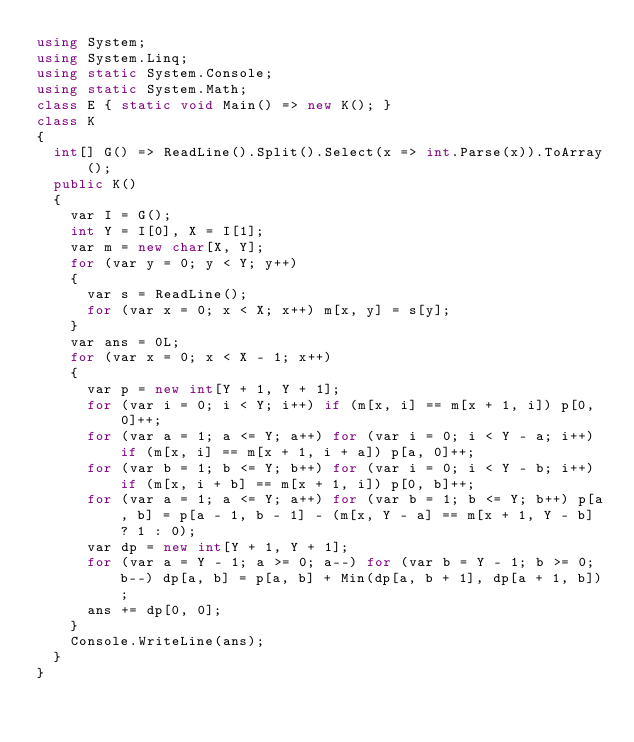<code> <loc_0><loc_0><loc_500><loc_500><_C#_>using System;
using System.Linq;
using static System.Console;
using static System.Math;
class E { static void Main() => new K(); }
class K
{
	int[] G() => ReadLine().Split().Select(x => int.Parse(x)).ToArray();
	public K()
	{
		var I = G();
		int Y = I[0], X = I[1];
		var m = new char[X, Y];
		for (var y = 0; y < Y; y++)
		{
			var s = ReadLine();
			for (var x = 0; x < X; x++) m[x, y] = s[y];
		}
		var ans = 0L;
		for (var x = 0; x < X - 1; x++)
		{
			var p = new int[Y + 1, Y + 1];
			for (var i = 0; i < Y; i++) if (m[x, i] == m[x + 1, i]) p[0, 0]++;
			for (var a = 1; a <= Y; a++) for (var i = 0; i < Y - a; i++) if (m[x, i] == m[x + 1, i + a]) p[a, 0]++;
			for (var b = 1; b <= Y; b++) for (var i = 0; i < Y - b; i++) if (m[x, i + b] == m[x + 1, i]) p[0, b]++;
			for (var a = 1; a <= Y; a++) for (var b = 1; b <= Y; b++) p[a, b] = p[a - 1, b - 1] - (m[x, Y - a] == m[x + 1, Y - b] ? 1 : 0);
			var dp = new int[Y + 1, Y + 1];
			for (var a = Y - 1; a >= 0; a--) for (var b = Y - 1; b >= 0; b--) dp[a, b] = p[a, b] + Min(dp[a, b + 1], dp[a + 1, b]);
			ans += dp[0, 0];
		}
		Console.WriteLine(ans);
	}
}
</code> 